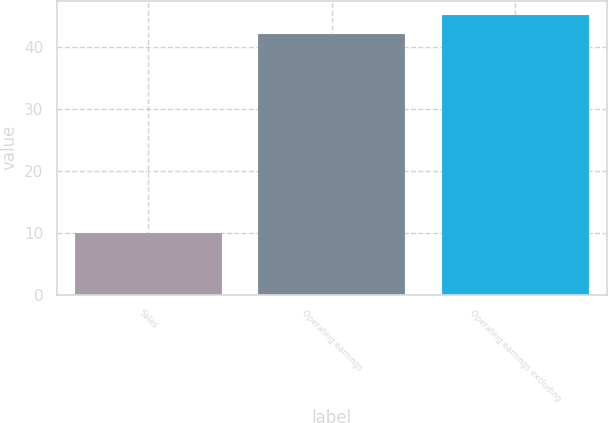Convert chart. <chart><loc_0><loc_0><loc_500><loc_500><bar_chart><fcel>Sales<fcel>Operating earnings<fcel>Operating earnings excluding<nl><fcel>10<fcel>42<fcel>45.2<nl></chart> 